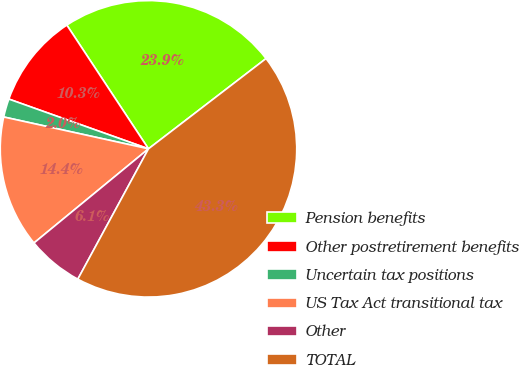Convert chart. <chart><loc_0><loc_0><loc_500><loc_500><pie_chart><fcel>Pension benefits<fcel>Other postretirement benefits<fcel>Uncertain tax positions<fcel>US Tax Act transitional tax<fcel>Other<fcel>TOTAL<nl><fcel>23.86%<fcel>10.27%<fcel>2.0%<fcel>14.4%<fcel>6.14%<fcel>43.33%<nl></chart> 